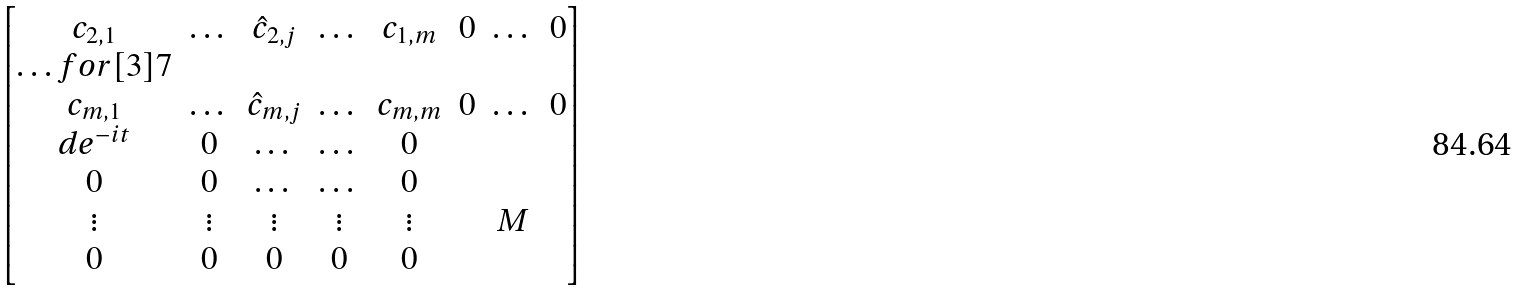Convert formula to latex. <formula><loc_0><loc_0><loc_500><loc_500>\begin{bmatrix} c _ { 2 , 1 } & \dots & \hat { c } _ { 2 , j } & \dots & c _ { 1 , m } & 0 & \dots & 0 \\ \hdots f o r [ 3 ] { 7 } \\ c _ { m , 1 } & \dots & \hat { c } _ { m , j } & \dots & c _ { m , m } & 0 & \dots & 0 \\ d e ^ { - i t } & 0 & \dots & \dots & 0 & & & \\ 0 & 0 & \dots & \dots & 0 & & & \\ \vdots & \vdots & \vdots & \vdots & \vdots & & M & \\ 0 & 0 & 0 & 0 & 0 & & & \\ \end{bmatrix}</formula> 